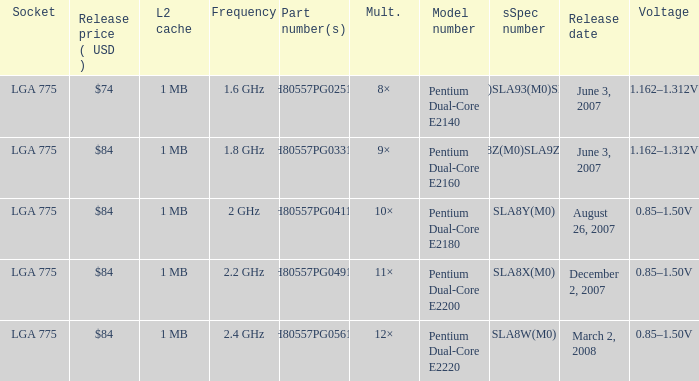What's the voltage for the pentium dual-core e2140? 1.162–1.312V. 